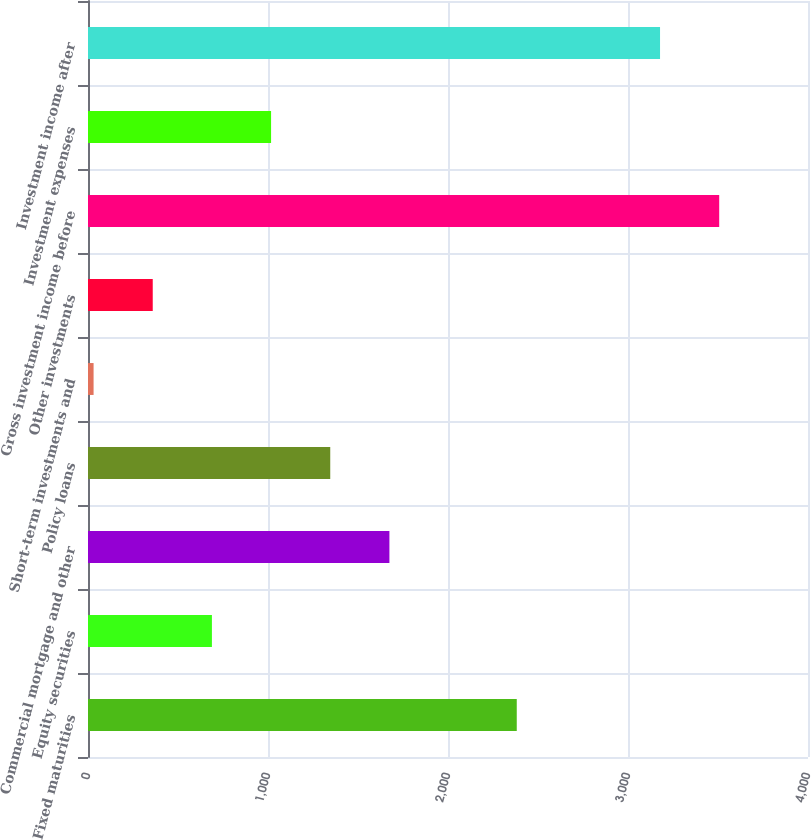Convert chart to OTSL. <chart><loc_0><loc_0><loc_500><loc_500><bar_chart><fcel>Fixed maturities<fcel>Equity securities<fcel>Commercial mortgage and other<fcel>Policy loans<fcel>Short-term investments and<fcel>Other investments<fcel>Gross investment income before<fcel>Investment expenses<fcel>Investment income after<nl><fcel>2382<fcel>688.4<fcel>1674.5<fcel>1345.8<fcel>31<fcel>359.7<fcel>3506.7<fcel>1017.1<fcel>3178<nl></chart> 